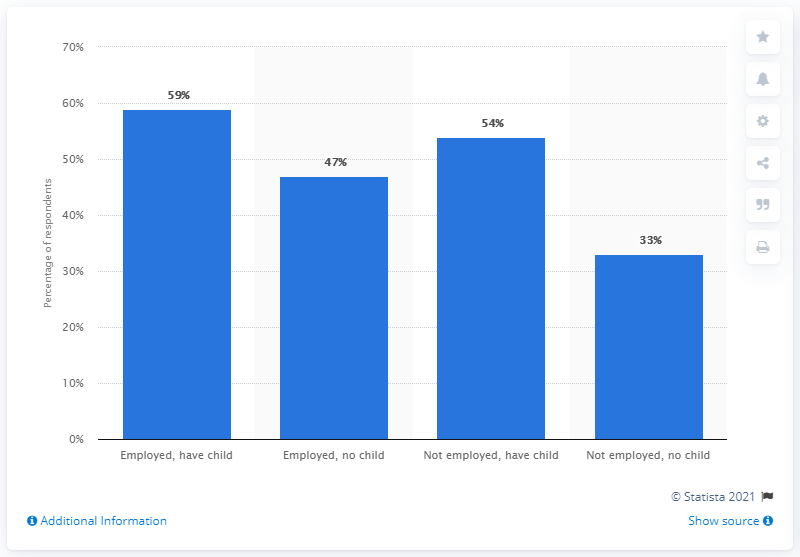Identify some key points in this picture. Approximately 80 people do not have children. Approximately 59% of individuals employed have children. 